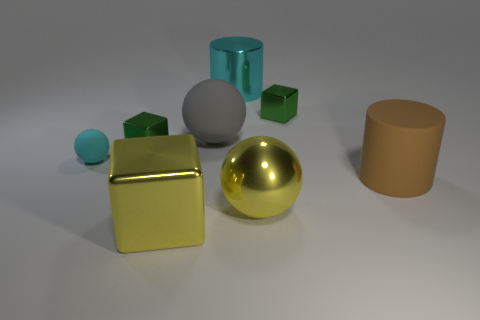There is a shiny object that is the same color as the tiny ball; what shape is it? The shiny object that shares the color with the small teal ball is a cylinder. It reflects light and has a smooth surface, signifying that it's likely made out of a metallic material, similar to the other geometric objects in the composition. 